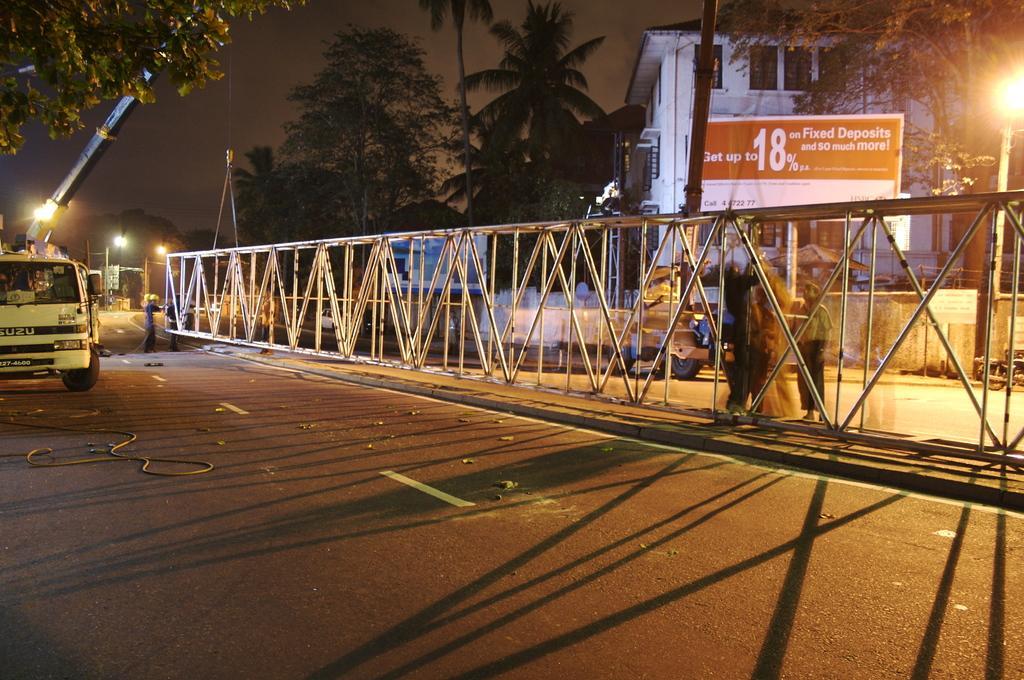Describe this image in one or two sentences. In this picture we can find few people and vehicles on the road, in the middle of the road we can find metal rods, in the background we can see few trees, lights, poles and a house. 